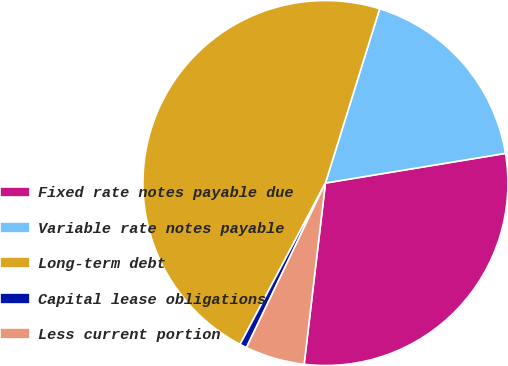Convert chart to OTSL. <chart><loc_0><loc_0><loc_500><loc_500><pie_chart><fcel>Fixed rate notes payable due<fcel>Variable rate notes payable<fcel>Long-term debt<fcel>Capital lease obligations<fcel>Less current portion<nl><fcel>29.46%<fcel>17.6%<fcel>47.06%<fcel>0.62%<fcel>5.26%<nl></chart> 